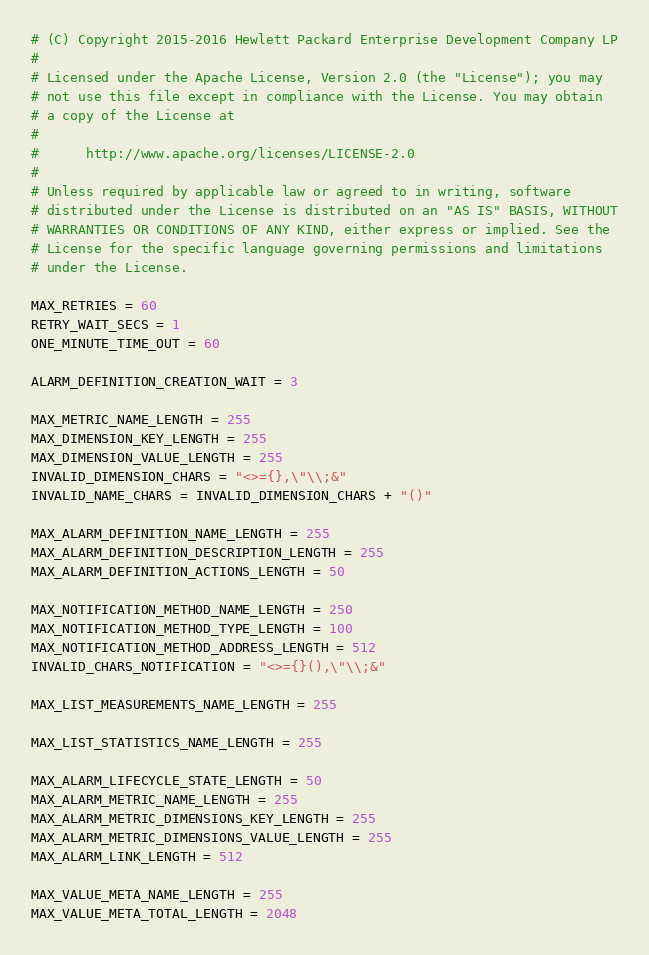<code> <loc_0><loc_0><loc_500><loc_500><_Python_># (C) Copyright 2015-2016 Hewlett Packard Enterprise Development Company LP
#
# Licensed under the Apache License, Version 2.0 (the "License"); you may
# not use this file except in compliance with the License. You may obtain
# a copy of the License at
#
#      http://www.apache.org/licenses/LICENSE-2.0
#
# Unless required by applicable law or agreed to in writing, software
# distributed under the License is distributed on an "AS IS" BASIS, WITHOUT
# WARRANTIES OR CONDITIONS OF ANY KIND, either express or implied. See the
# License for the specific language governing permissions and limitations
# under the License.

MAX_RETRIES = 60
RETRY_WAIT_SECS = 1
ONE_MINUTE_TIME_OUT = 60

ALARM_DEFINITION_CREATION_WAIT = 3

MAX_METRIC_NAME_LENGTH = 255
MAX_DIMENSION_KEY_LENGTH = 255
MAX_DIMENSION_VALUE_LENGTH = 255
INVALID_DIMENSION_CHARS = "<>={},\"\\;&"
INVALID_NAME_CHARS = INVALID_DIMENSION_CHARS + "()"

MAX_ALARM_DEFINITION_NAME_LENGTH = 255
MAX_ALARM_DEFINITION_DESCRIPTION_LENGTH = 255
MAX_ALARM_DEFINITION_ACTIONS_LENGTH = 50

MAX_NOTIFICATION_METHOD_NAME_LENGTH = 250
MAX_NOTIFICATION_METHOD_TYPE_LENGTH = 100
MAX_NOTIFICATION_METHOD_ADDRESS_LENGTH = 512
INVALID_CHARS_NOTIFICATION = "<>={}(),\"\\;&"

MAX_LIST_MEASUREMENTS_NAME_LENGTH = 255

MAX_LIST_STATISTICS_NAME_LENGTH = 255

MAX_ALARM_LIFECYCLE_STATE_LENGTH = 50
MAX_ALARM_METRIC_NAME_LENGTH = 255
MAX_ALARM_METRIC_DIMENSIONS_KEY_LENGTH = 255
MAX_ALARM_METRIC_DIMENSIONS_VALUE_LENGTH = 255
MAX_ALARM_LINK_LENGTH = 512

MAX_VALUE_META_NAME_LENGTH = 255
MAX_VALUE_META_TOTAL_LENGTH = 2048
</code> 